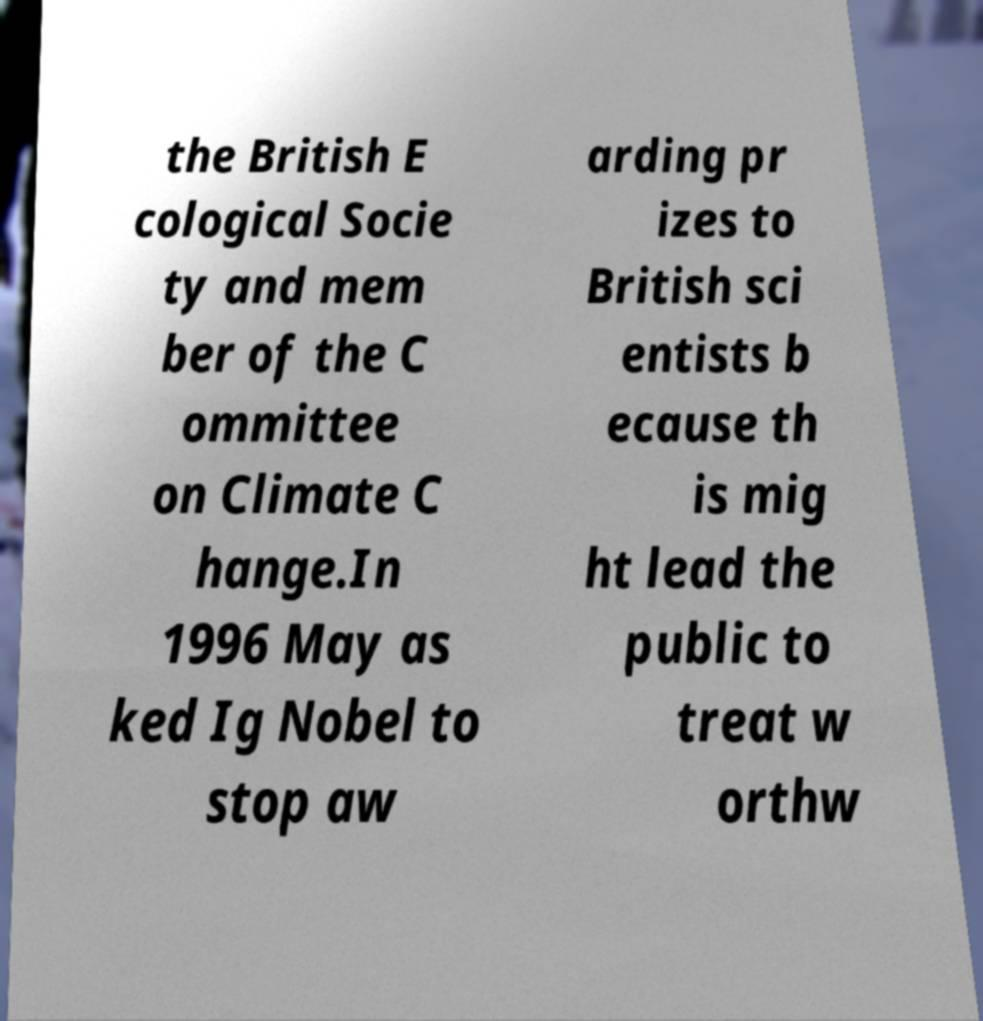Please read and relay the text visible in this image. What does it say? the British E cological Socie ty and mem ber of the C ommittee on Climate C hange.In 1996 May as ked Ig Nobel to stop aw arding pr izes to British sci entists b ecause th is mig ht lead the public to treat w orthw 